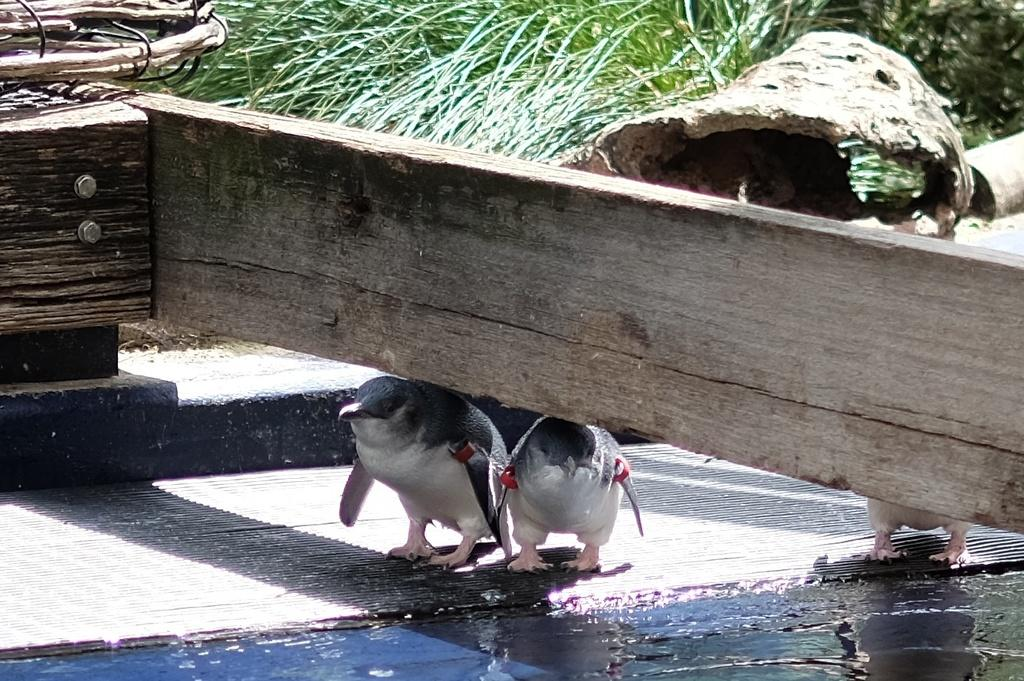What type of animals are in the image? There are two Gentoo penguins in the image. What is located above the penguins? There is a wooden object above the penguins. What can be seen in the background of the image? There is grass in the background of the image. What question is the penguin asking in the image? There is no indication in the image that the penguin is asking a question, as penguins do not have the ability to speak or ask questions. 